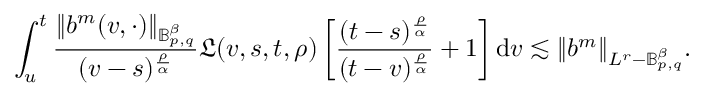<formula> <loc_0><loc_0><loc_500><loc_500>\int _ { u } ^ { t } \frac { \| b ^ { m } ( v , \cdot ) \| _ { \mathbb { B } _ { p , q } ^ { \beta } } } { ( v - s ) ^ { \frac { \rho } { \alpha } } } \mathfrak { L } ( v , s , t , \rho ) \left [ \frac { ( t - s ) ^ { \frac { \rho } { \alpha } } } { ( t - v ) ^ { \frac { \rho } { \alpha } } } + 1 \right ] d v \lesssim \| b ^ { m } \| _ { L ^ { r } - \mathbb { B } _ { p , q } ^ { \beta } } .</formula> 